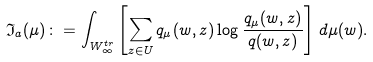<formula> <loc_0><loc_0><loc_500><loc_500>\mathfrak { I } _ { a } ( \mu ) \colon = \int _ { W _ { \infty } ^ { t r } } \left [ \sum _ { z \in U } q _ { \mu } ( w , z ) \log \frac { q _ { \mu } ( w , z ) } { q ( w , z ) } \right ] \, d \mu ( w ) .</formula> 